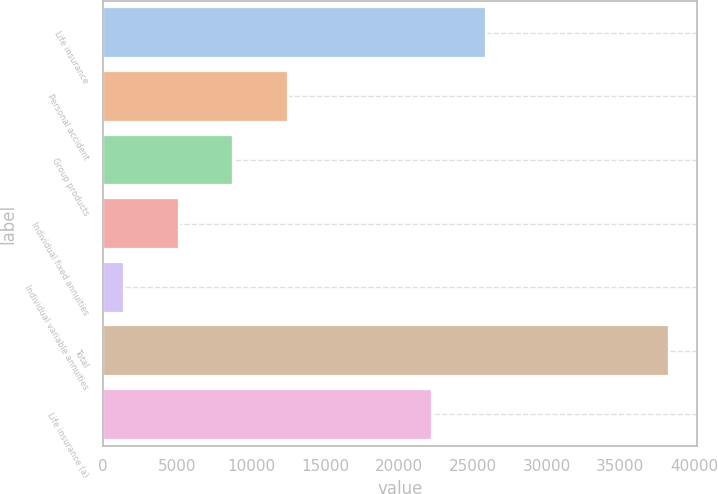Convert chart. <chart><loc_0><loc_0><loc_500><loc_500><bar_chart><fcel>Life insurance<fcel>Personal accident<fcel>Group products<fcel>Individual fixed annuities<fcel>Individual variable annuities<fcel>Total<fcel>Life insurance (a)<nl><fcel>25926.9<fcel>12475.7<fcel>8791.8<fcel>5107.9<fcel>1424<fcel>38263<fcel>22243<nl></chart> 